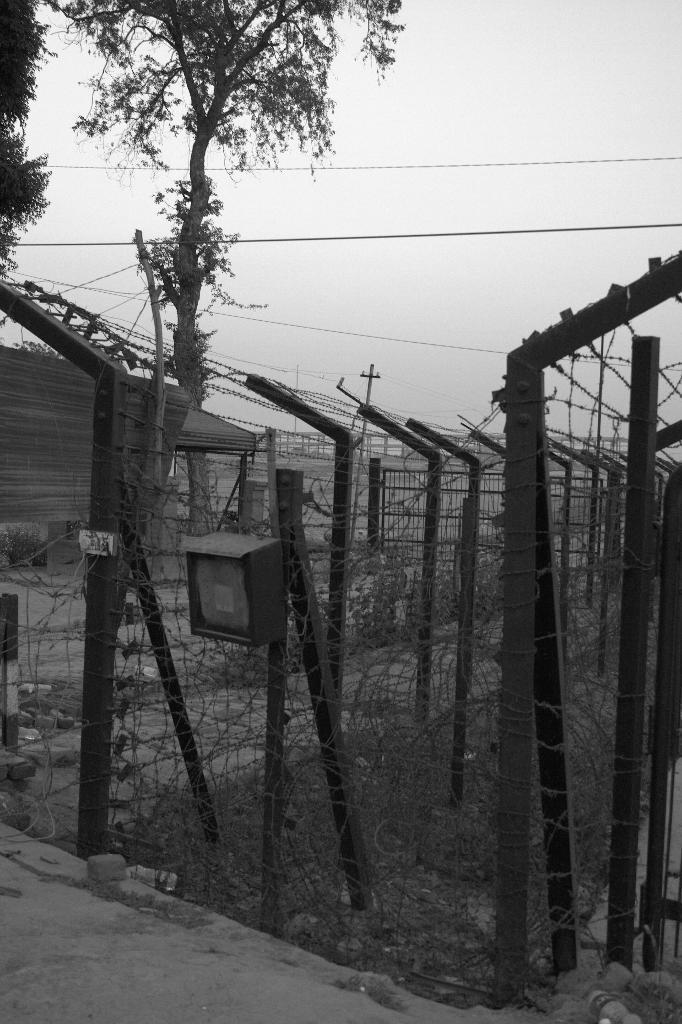Please provide a concise description of this image. A black and white picture. Here we can see trees. A fence with rods. 